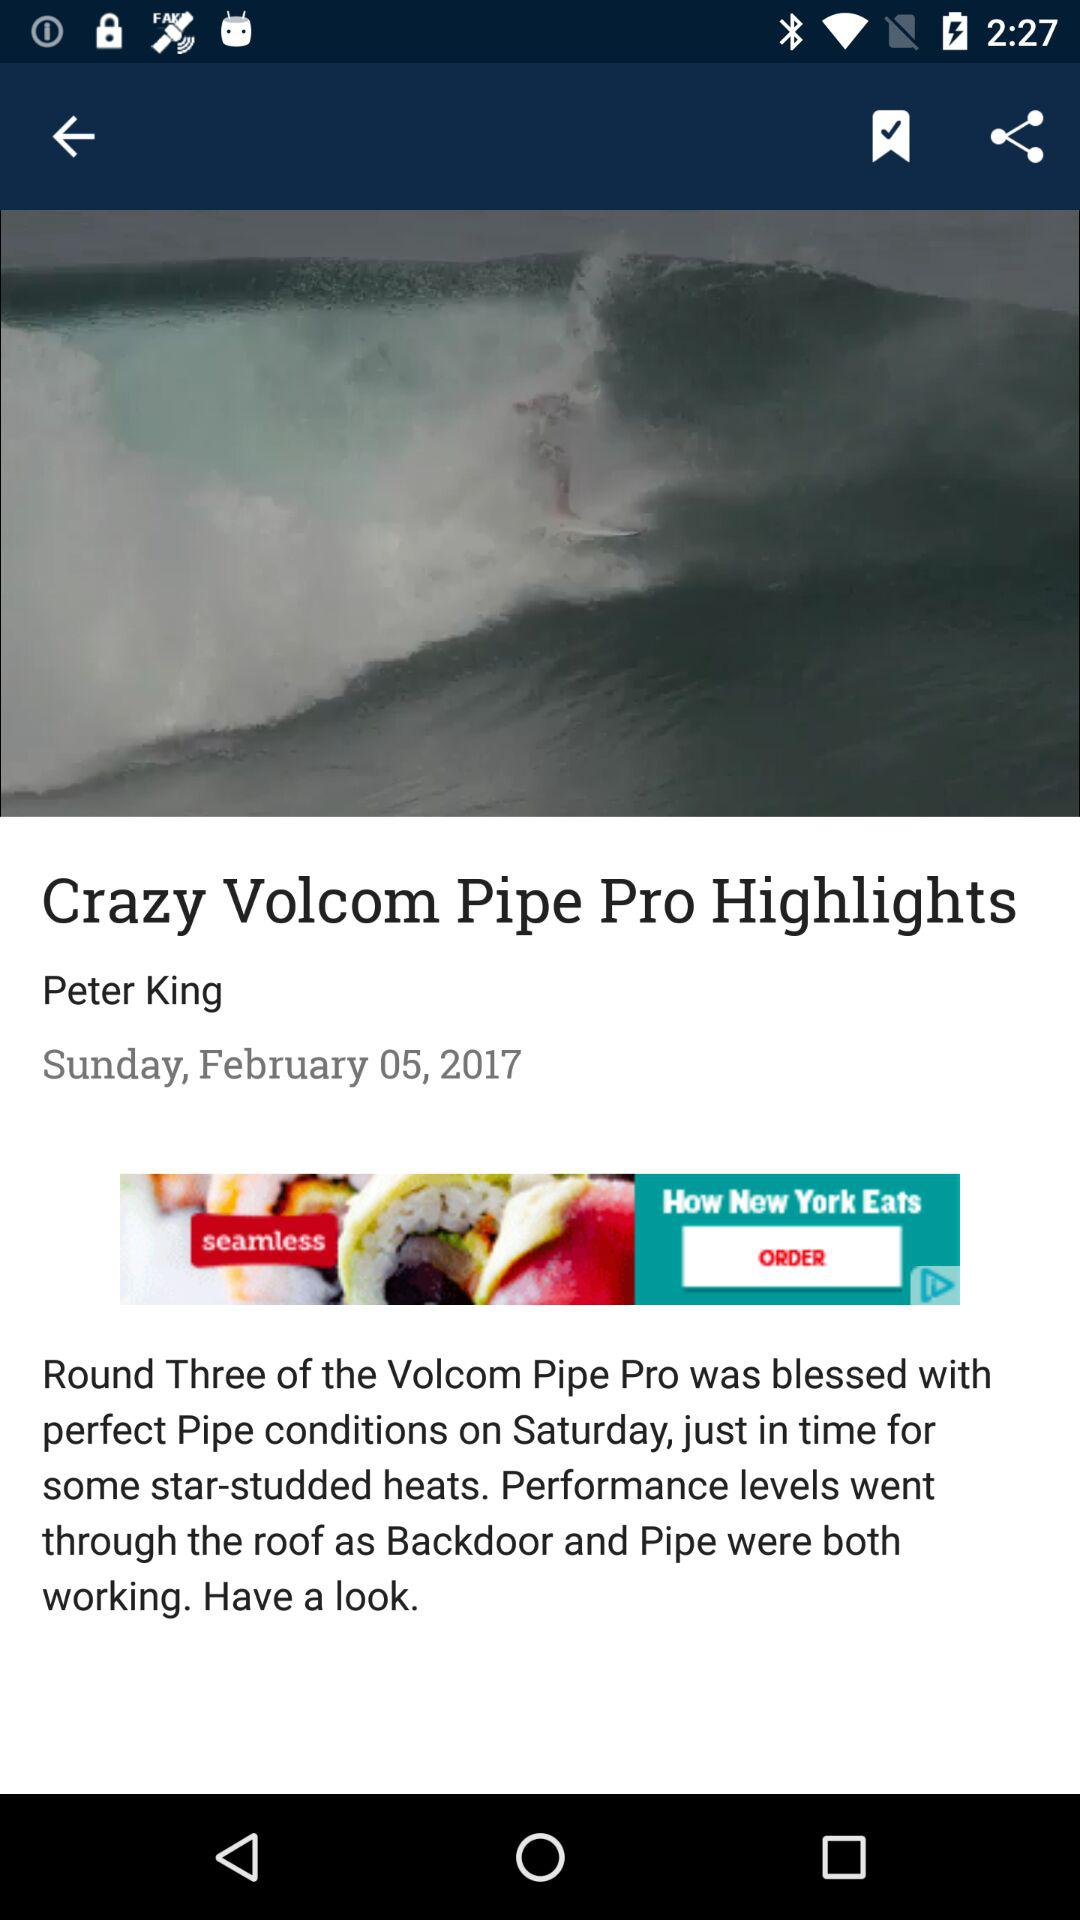What is the headline? The headline is "Crazy Volcom Pipe Pro Highlights". 